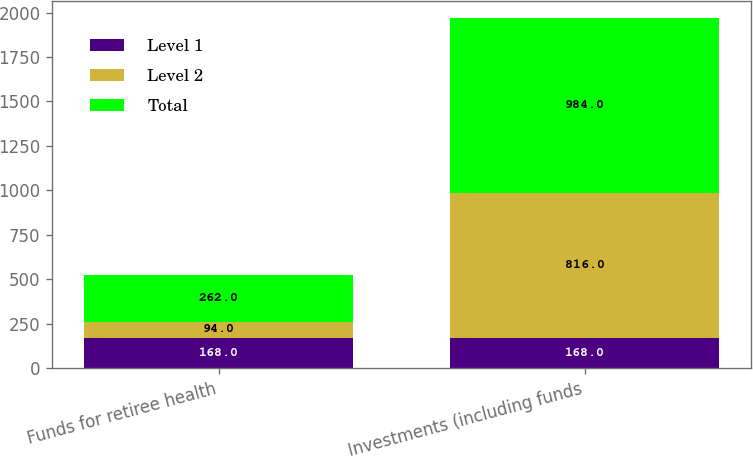Convert chart to OTSL. <chart><loc_0><loc_0><loc_500><loc_500><stacked_bar_chart><ecel><fcel>Funds for retiree health<fcel>Investments (including funds<nl><fcel>Level 1<fcel>168<fcel>168<nl><fcel>Level 2<fcel>94<fcel>816<nl><fcel>Total<fcel>262<fcel>984<nl></chart> 